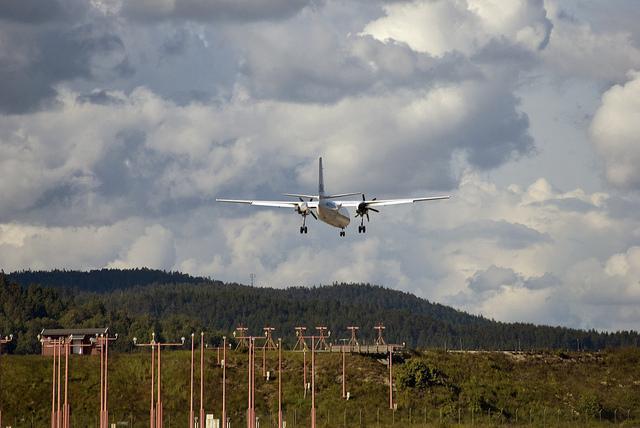How many planes are going right?
Give a very brief answer. 1. 